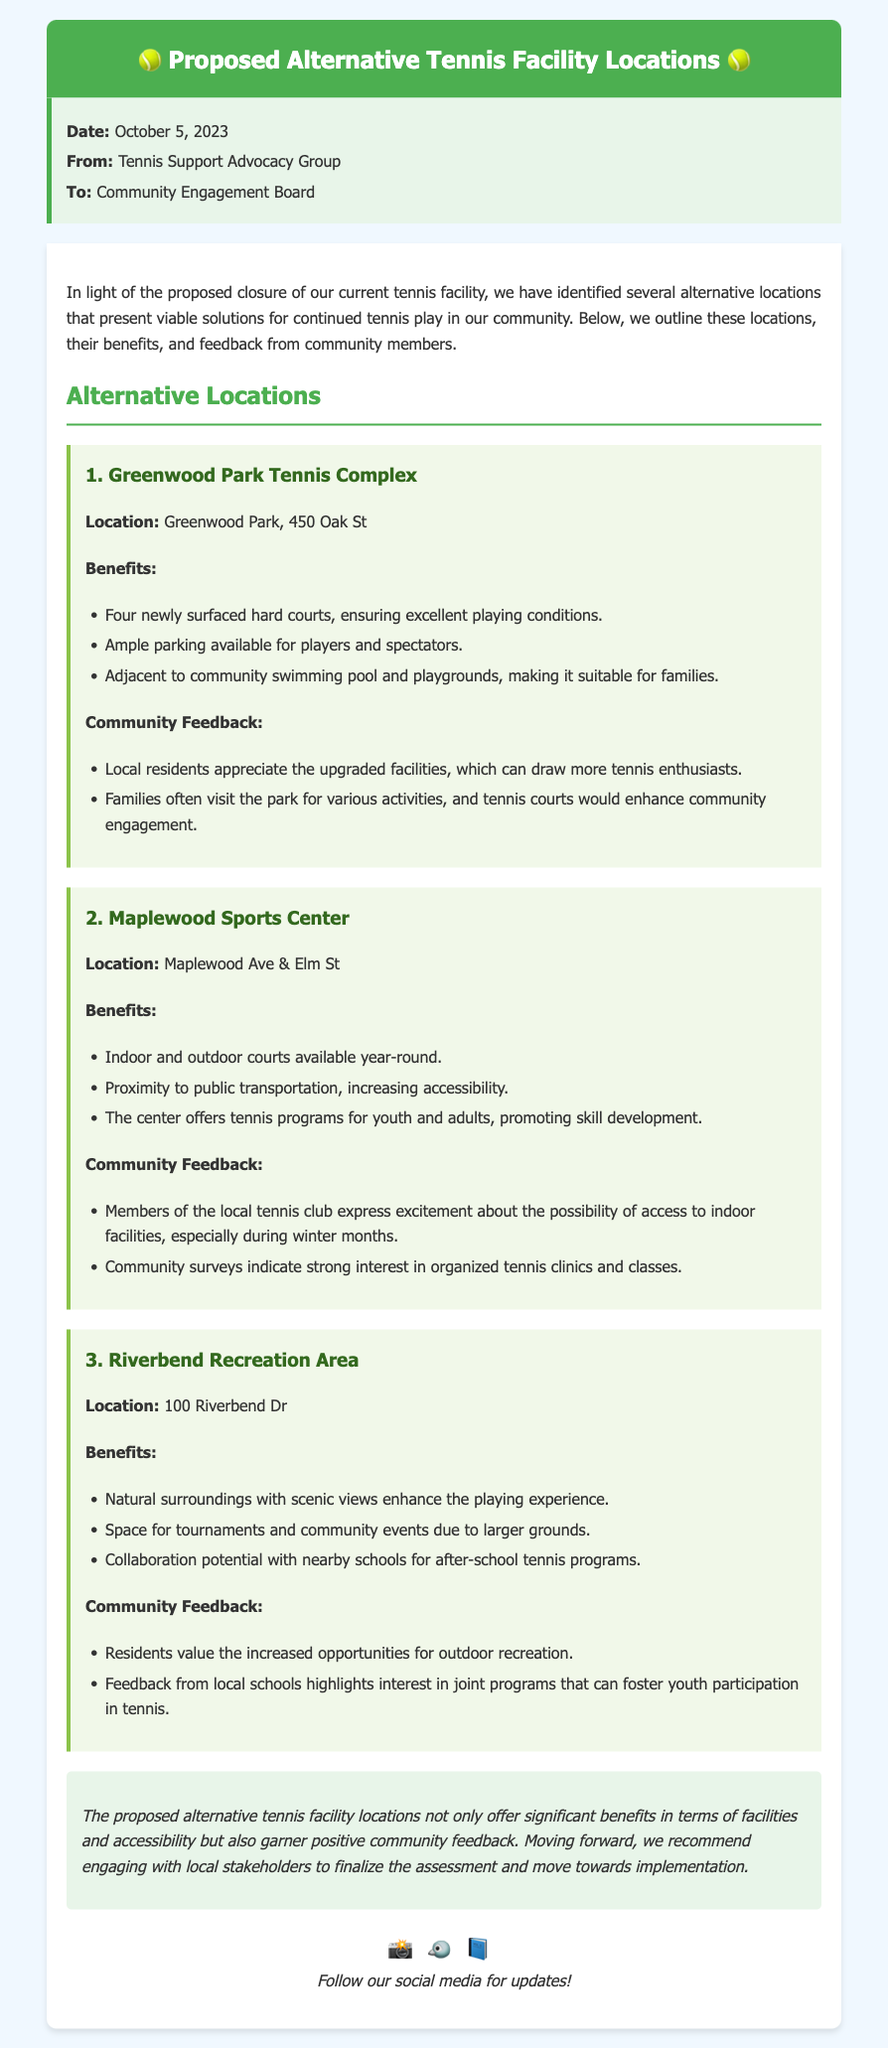What is the date of the memo? The date of the memo is explicitly stated in the document.
Answer: October 5, 2023 Who is the memo from? The sender of the memo is noted in the memo details section.
Answer: Tennis Support Advocacy Group How many tennis courts are available at Greenwood Park Tennis Complex? The number of courts is mentioned in the benefits of the location section.
Answer: Four What is a key feature of the Maplewood Sports Center? Key features are listed under benefits, highlighting multiple aspects of the location.
Answer: Indoor and outdoor courts Which location has potential collaboration with schools for programs? The document mentions collaboration potential specific to one location in the benefits section.
Answer: Riverbend Recreation Area What community feedback is associated with Riverbend Recreation Area? The feedback provided references specific sentiments from local residents about outdoor recreation.
Answer: Increased opportunities for outdoor recreation What type of tennis programs does Maplewood Sports Center offer? The memo details the programs available at Maplewood Sports Center, highlighting age groups.
Answer: Programs for youth and adults What is a benefit of the Greenwood Park Tennis Complex for families? The benefits section mentions specific features that appeal to families at this location.
Answer: Adjacent to community swimming pool and playgrounds What is the overarching conclusion about the proposed locations? The conclusion summarizes the benefits and community sentiments regarding all proposed locations.
Answer: Significant benefits in terms of facilities and accessibility 